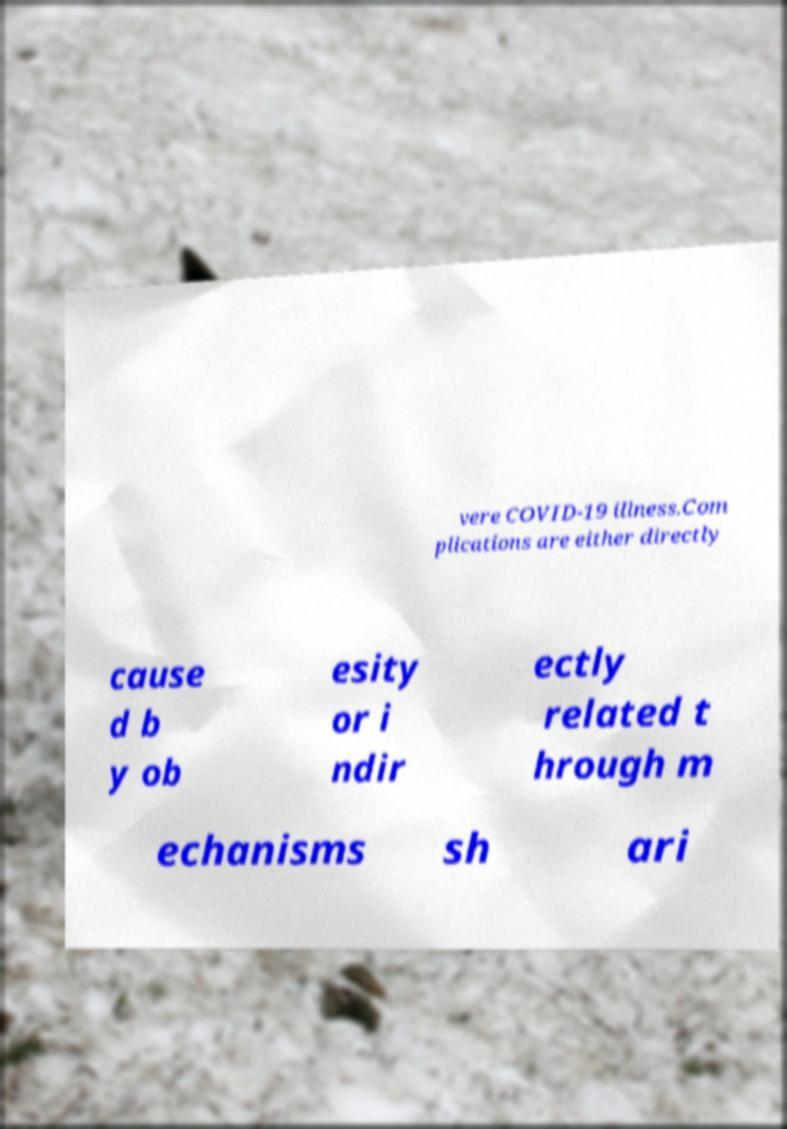Could you extract and type out the text from this image? vere COVID-19 illness.Com plications are either directly cause d b y ob esity or i ndir ectly related t hrough m echanisms sh ari 